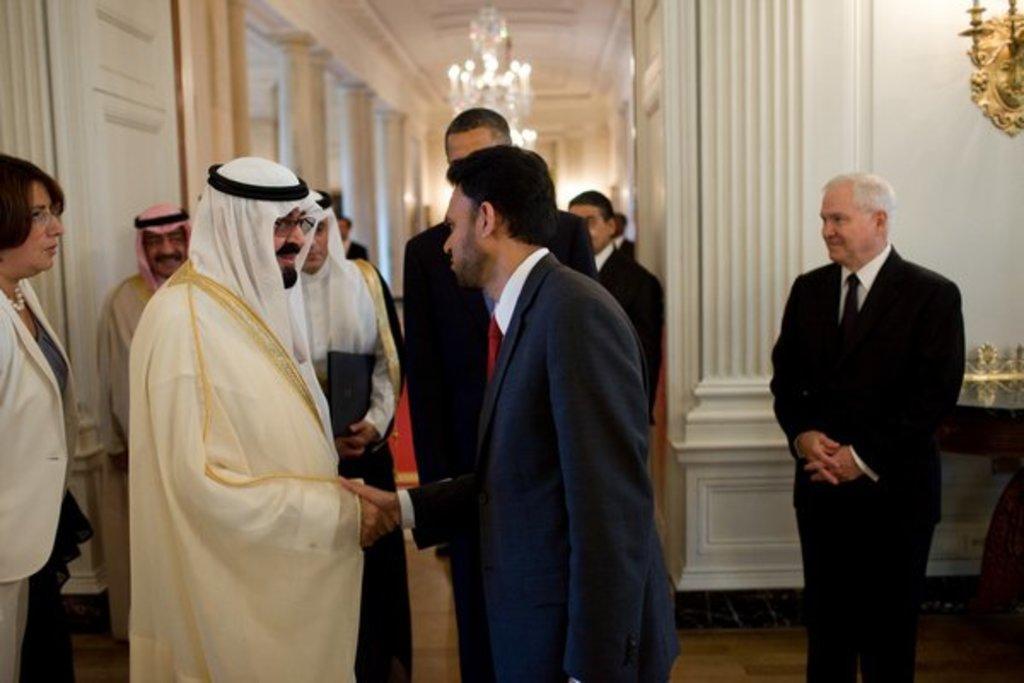Could you give a brief overview of what you see in this image? In this image in front there are people standing on the floor. On the right side of the image there is a table and on top of it there are few objects. There is a wall with idol on it. In the background of the image there is a chandelier. On the left side of the image there are pillars. 